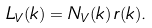Convert formula to latex. <formula><loc_0><loc_0><loc_500><loc_500>L _ { V } ( k ) = N _ { V } ( k ) \, r ( k ) .</formula> 